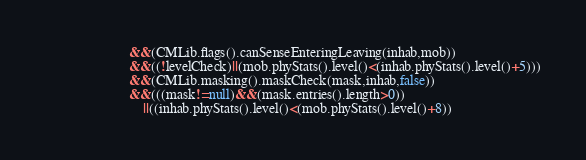<code> <loc_0><loc_0><loc_500><loc_500><_Java_>						&&(CMLib.flags().canSenseEnteringLeaving(inhab,mob))
						&&((!levelCheck)||(mob.phyStats().level()<(inhab.phyStats().level()+5)))
						&&(CMLib.masking().maskCheck(mask,inhab,false))
						&&(((mask!=null)&&(mask.entries().length>0))
							||((inhab.phyStats().level()<(mob.phyStats().level()+8))</code> 